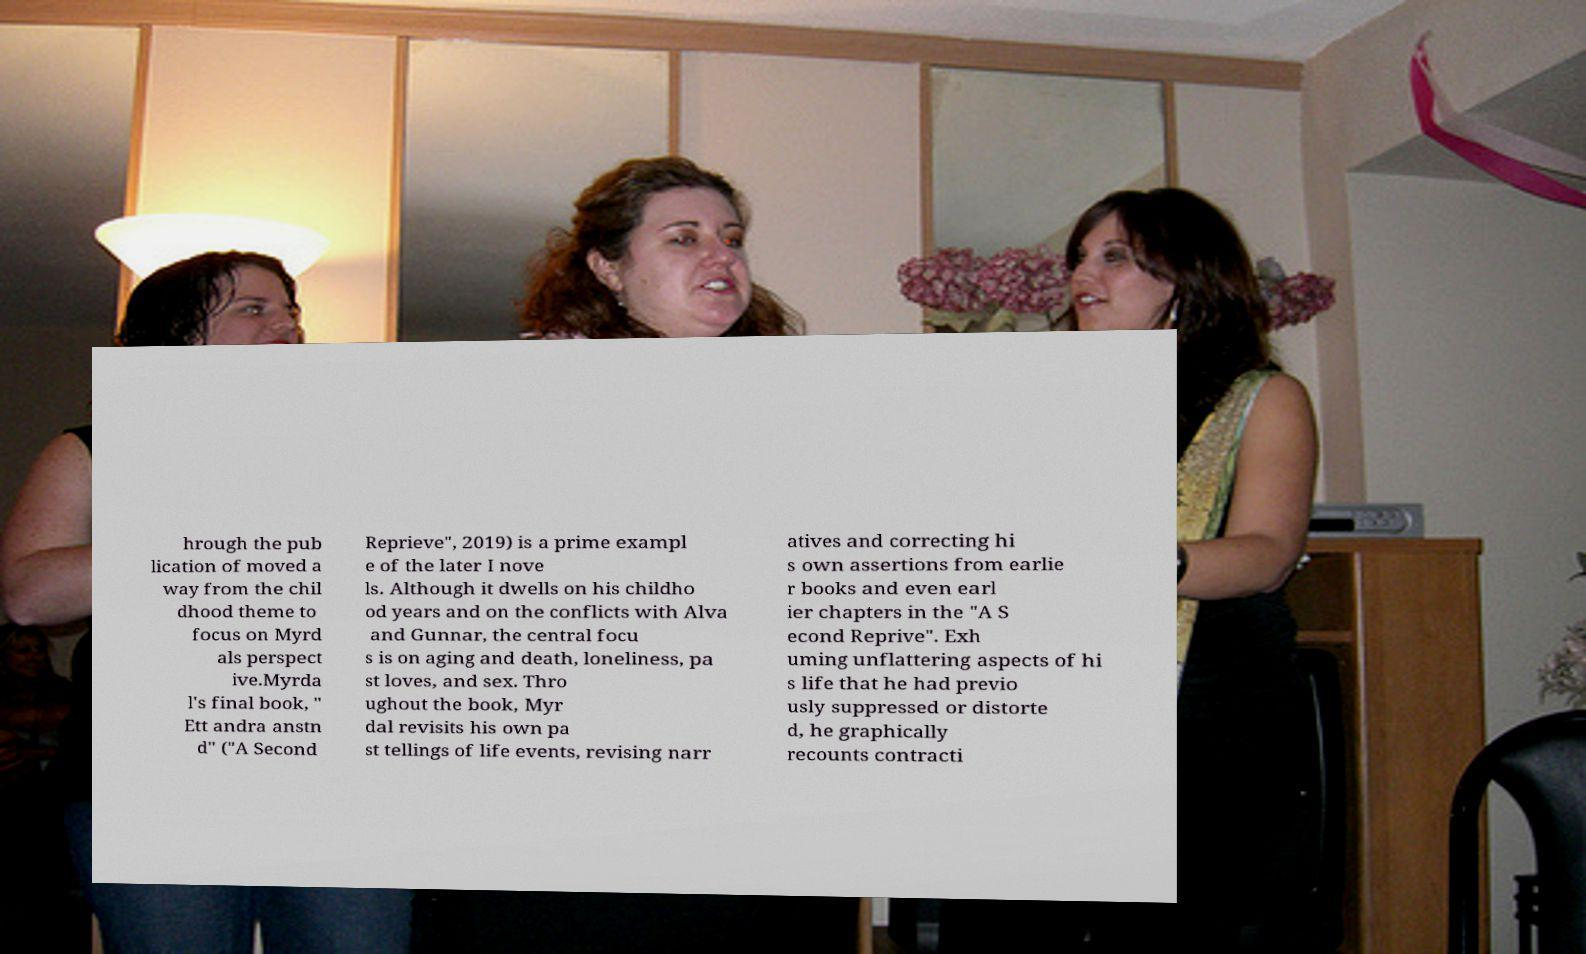Please read and relay the text visible in this image. What does it say? hrough the pub lication of moved a way from the chil dhood theme to focus on Myrd als perspect ive.Myrda l's final book, " Ett andra anstn d" ("A Second Reprieve", 2019) is a prime exampl e of the later I nove ls. Although it dwells on his childho od years and on the conflicts with Alva and Gunnar, the central focu s is on aging and death, loneliness, pa st loves, and sex. Thro ughout the book, Myr dal revisits his own pa st tellings of life events, revising narr atives and correcting hi s own assertions from earlie r books and even earl ier chapters in the "A S econd Reprive". Exh uming unflattering aspects of hi s life that he had previo usly suppressed or distorte d, he graphically recounts contracti 